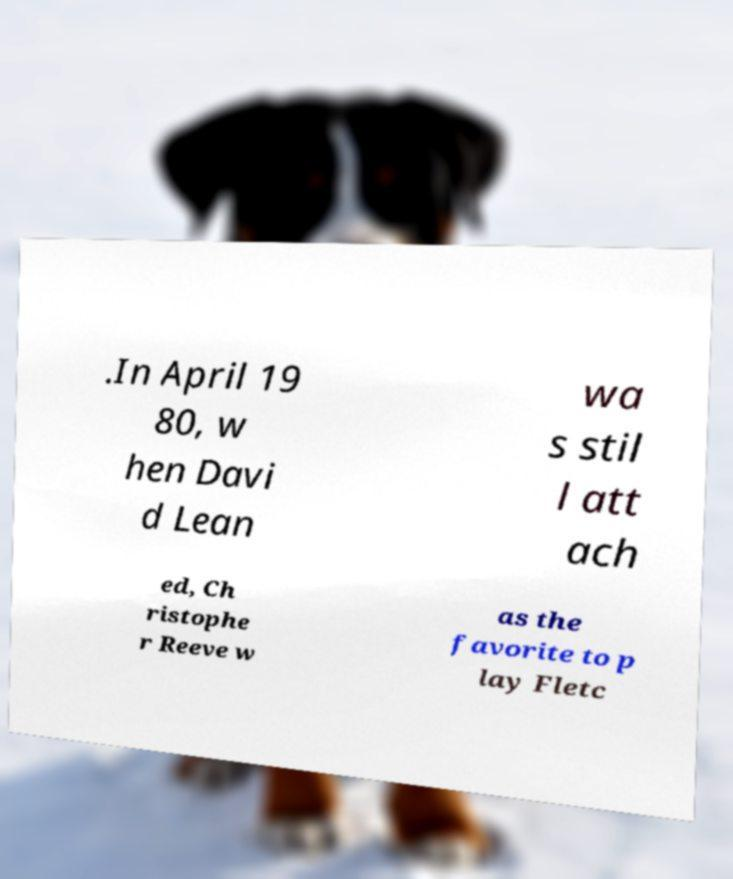For documentation purposes, I need the text within this image transcribed. Could you provide that? .In April 19 80, w hen Davi d Lean wa s stil l att ach ed, Ch ristophe r Reeve w as the favorite to p lay Fletc 